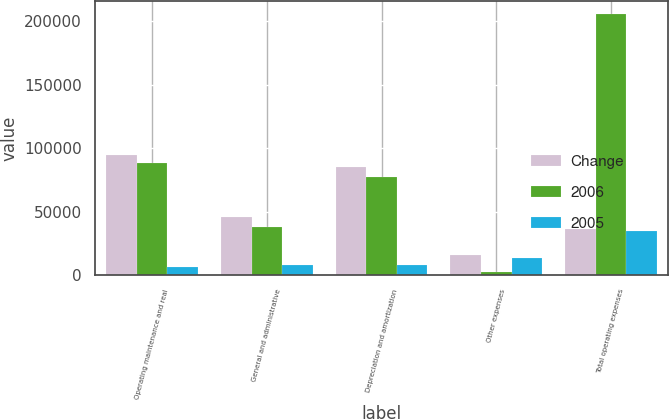Convert chart to OTSL. <chart><loc_0><loc_0><loc_500><loc_500><stacked_bar_chart><ecel><fcel>Operating maintenance and real<fcel>General and administrative<fcel>Depreciation and amortization<fcel>Other expenses<fcel>Total operating expenses<nl><fcel>Change<fcel>94405<fcel>45495<fcel>84694<fcel>15927<fcel>36388<nl><fcel>2006<fcel>88062<fcel>37815<fcel>76925<fcel>2758<fcel>205560<nl><fcel>2005<fcel>6343<fcel>7680<fcel>7769<fcel>13169<fcel>34961<nl></chart> 